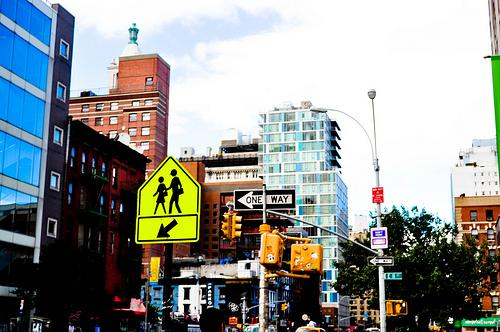Question: when do you stop at this intersection?
Choices:
A. When pedestrians are passing.
B. If ambulance is crossing.
C. If there is an accident.
D. When Light is Red.
Answer with the letter. Answer: D Question: what type of Day is it?
Choices:
A. Foggy.
B. Hazy.
C. Cloudy.
D. Rainy.
Answer with the letter. Answer: C Question: what color is the Pedestrian Walk sign?
Choices:
A. Orange.
B. Yellow.
C. White.
D. Black.
Answer with the letter. Answer: B Question: what distinguishes the Building on far left?
Choices:
A. Lots of Glass Windows.
B. Iron gate.
C. Garden.
D. Big driveway.
Answer with the letter. Answer: A 